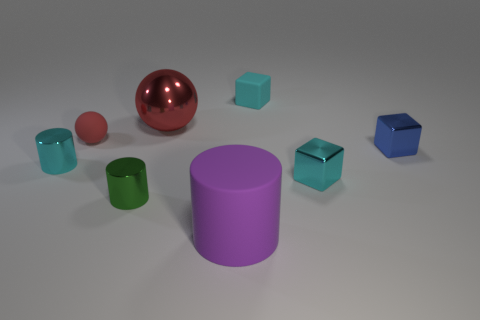There is a small rubber thing that is to the right of the large rubber cylinder; how many metallic things are on the left side of it?
Ensure brevity in your answer.  3. Is the color of the large object behind the green cylinder the same as the tiny rubber sphere?
Your response must be concise. Yes. What number of objects are purple cylinders or things that are to the left of the red metal object?
Offer a very short reply. 4. There is a small shiny object in front of the cyan metal cube; does it have the same shape as the matte thing that is in front of the tiny red rubber object?
Keep it short and to the point. Yes. Is there any other thing of the same color as the big matte cylinder?
Your answer should be compact. No. What shape is the other small thing that is made of the same material as the tiny red object?
Your answer should be compact. Cube. There is a thing that is both in front of the cyan metallic cylinder and behind the tiny green shiny object; what material is it?
Give a very brief answer. Metal. Is the color of the big sphere the same as the tiny ball?
Offer a terse response. Yes. There is a object that is the same color as the tiny ball; what is its shape?
Provide a succinct answer. Sphere. How many large red things have the same shape as the tiny red matte object?
Your answer should be very brief. 1. 